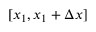<formula> <loc_0><loc_0><loc_500><loc_500>[ x _ { 1 } , x _ { 1 } + \Delta x ]</formula> 